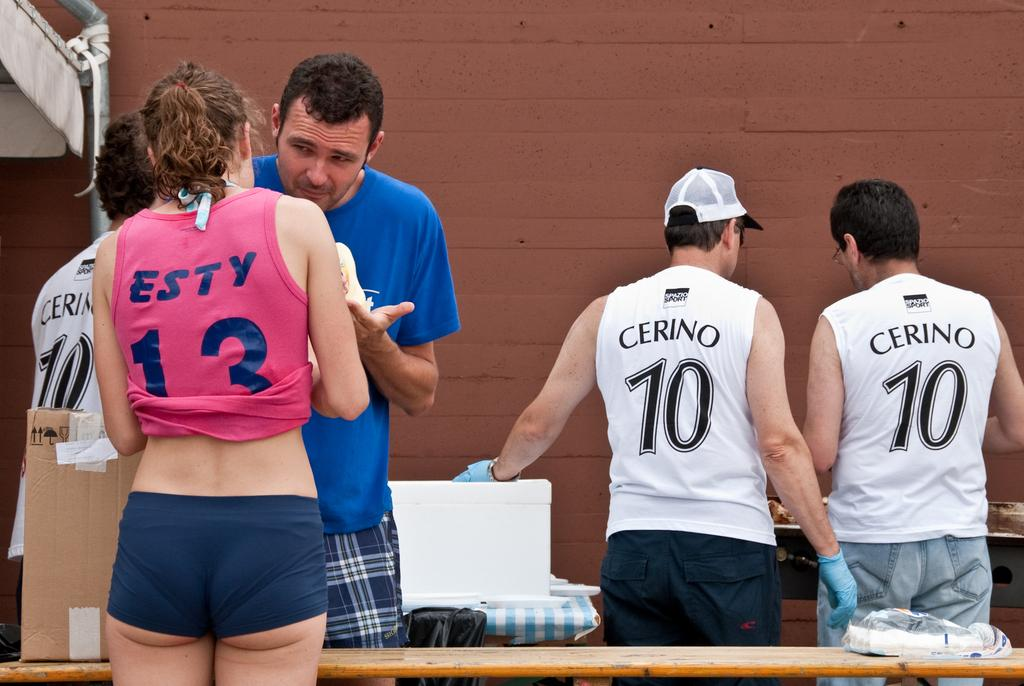<image>
Present a compact description of the photo's key features. The backs of people with Cerino and Esty shirts. 